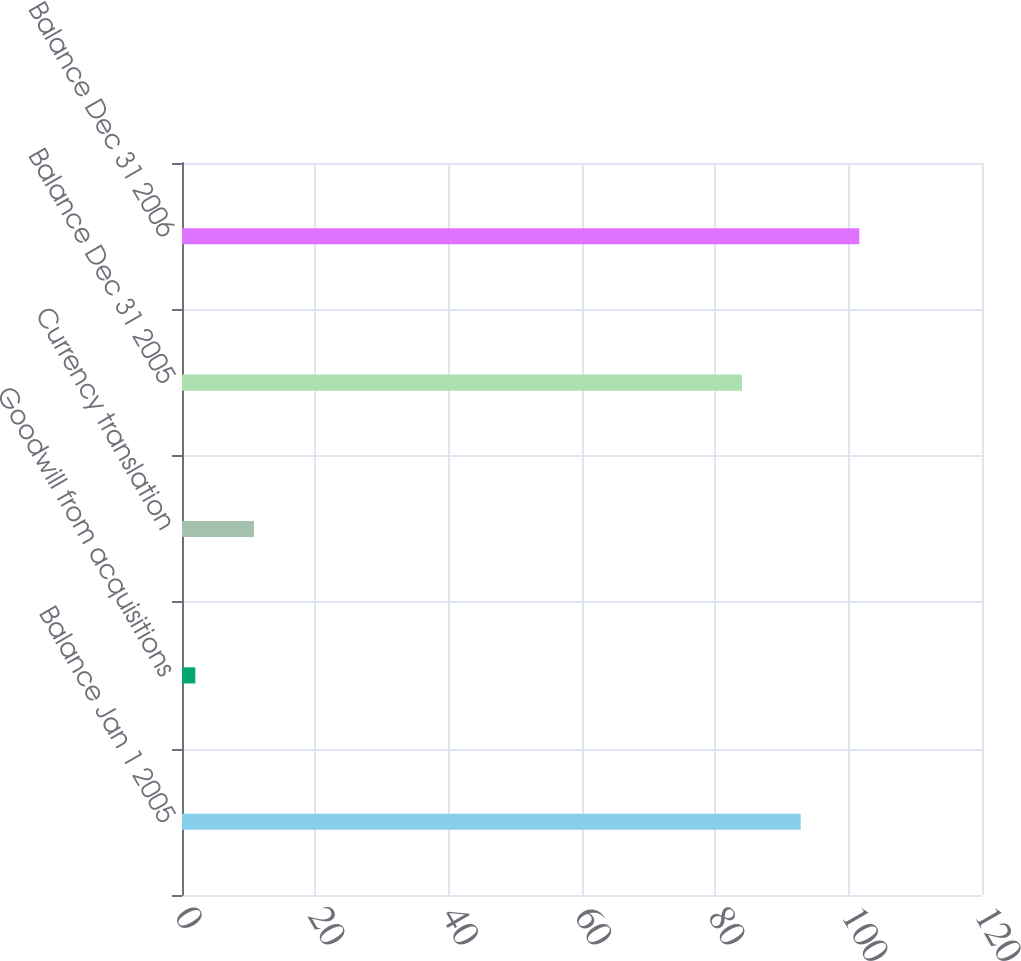<chart> <loc_0><loc_0><loc_500><loc_500><bar_chart><fcel>Balance Jan 1 2005<fcel>Goodwill from acquisitions<fcel>Currency translation<fcel>Balance Dec 31 2005<fcel>Balance Dec 31 2006<nl><fcel>92.8<fcel>2<fcel>10.8<fcel>84<fcel>101.6<nl></chart> 